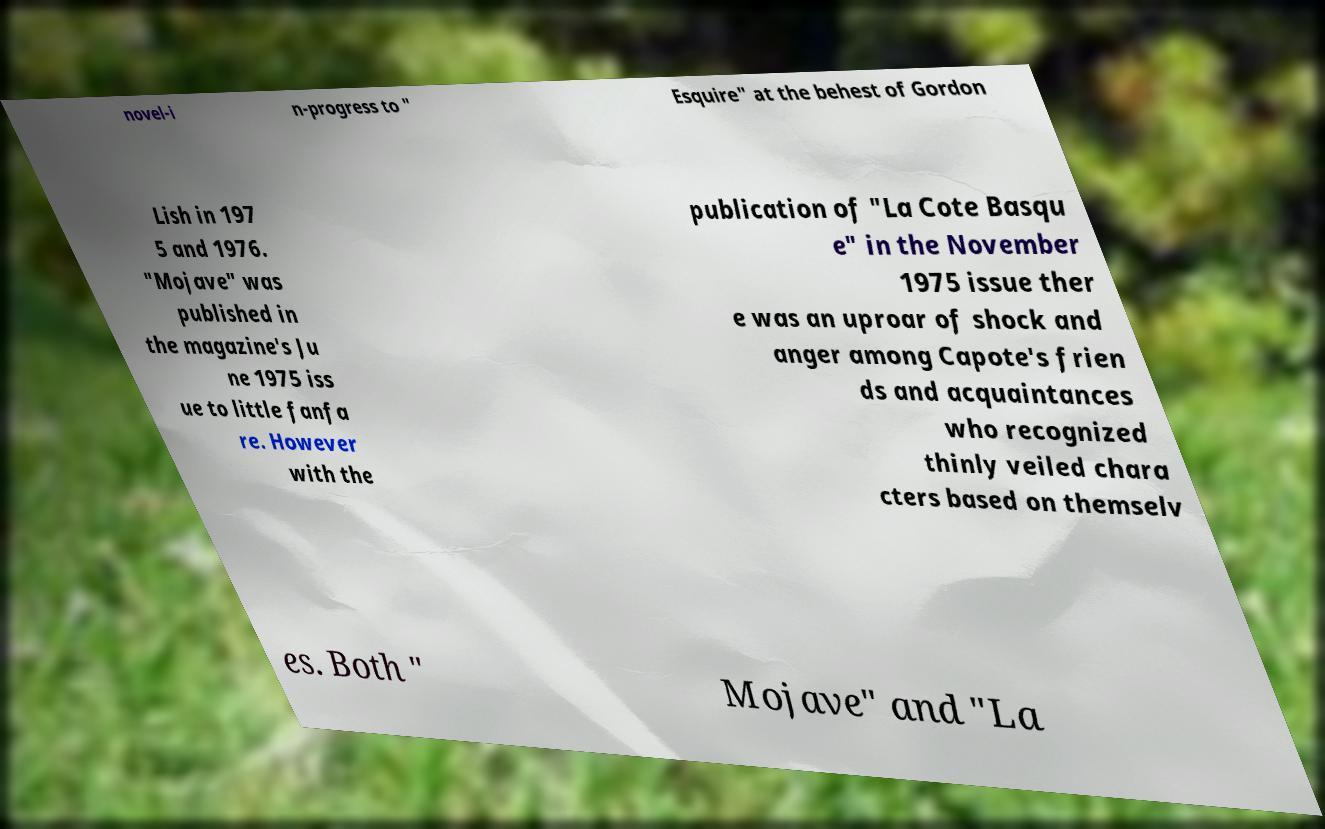Please read and relay the text visible in this image. What does it say? novel-i n-progress to " Esquire" at the behest of Gordon Lish in 197 5 and 1976. "Mojave" was published in the magazine's Ju ne 1975 iss ue to little fanfa re. However with the publication of "La Cote Basqu e" in the November 1975 issue ther e was an uproar of shock and anger among Capote's frien ds and acquaintances who recognized thinly veiled chara cters based on themselv es. Both " Mojave" and "La 